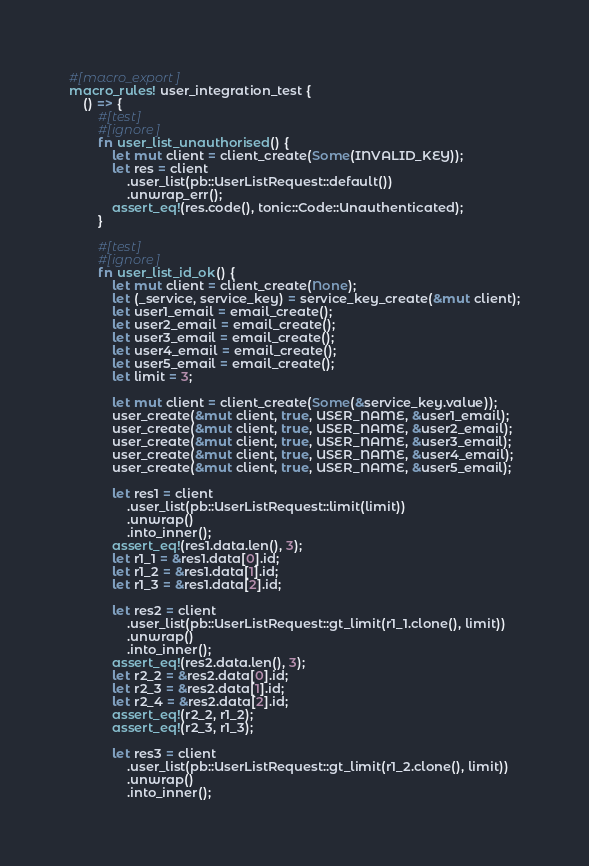Convert code to text. <code><loc_0><loc_0><loc_500><loc_500><_Rust_>#[macro_export]
macro_rules! user_integration_test {
    () => {
        #[test]
        #[ignore]
        fn user_list_unauthorised() {
            let mut client = client_create(Some(INVALID_KEY));
            let res = client
                .user_list(pb::UserListRequest::default())
                .unwrap_err();
            assert_eq!(res.code(), tonic::Code::Unauthenticated);
        }

        #[test]
        #[ignore]
        fn user_list_id_ok() {
            let mut client = client_create(None);
            let (_service, service_key) = service_key_create(&mut client);
            let user1_email = email_create();
            let user2_email = email_create();
            let user3_email = email_create();
            let user4_email = email_create();
            let user5_email = email_create();
            let limit = 3;

            let mut client = client_create(Some(&service_key.value));
            user_create(&mut client, true, USER_NAME, &user1_email);
            user_create(&mut client, true, USER_NAME, &user2_email);
            user_create(&mut client, true, USER_NAME, &user3_email);
            user_create(&mut client, true, USER_NAME, &user4_email);
            user_create(&mut client, true, USER_NAME, &user5_email);

            let res1 = client
                .user_list(pb::UserListRequest::limit(limit))
                .unwrap()
                .into_inner();
            assert_eq!(res1.data.len(), 3);
            let r1_1 = &res1.data[0].id;
            let r1_2 = &res1.data[1].id;
            let r1_3 = &res1.data[2].id;

            let res2 = client
                .user_list(pb::UserListRequest::gt_limit(r1_1.clone(), limit))
                .unwrap()
                .into_inner();
            assert_eq!(res2.data.len(), 3);
            let r2_2 = &res2.data[0].id;
            let r2_3 = &res2.data[1].id;
            let r2_4 = &res2.data[2].id;
            assert_eq!(r2_2, r1_2);
            assert_eq!(r2_3, r1_3);

            let res3 = client
                .user_list(pb::UserListRequest::gt_limit(r1_2.clone(), limit))
                .unwrap()
                .into_inner();</code> 